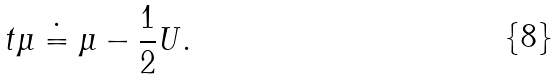Convert formula to latex. <formula><loc_0><loc_0><loc_500><loc_500>\ t { \mu } \doteq \mu - \frac { 1 } { 2 } U .</formula> 